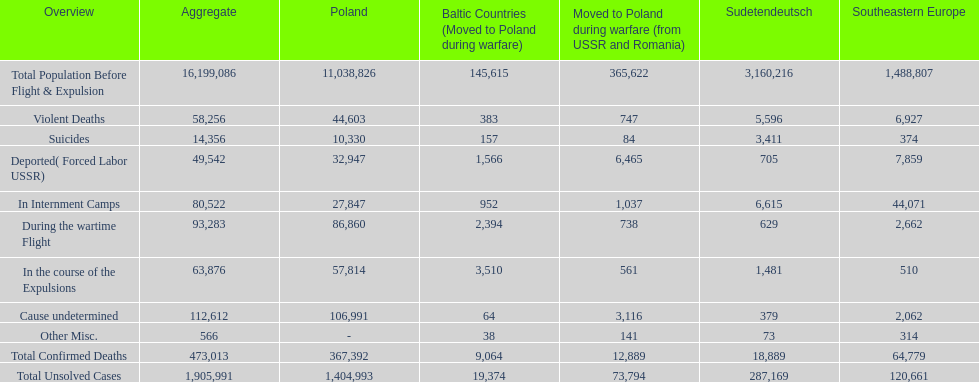Which region had the least total of unsolved cases? Baltic States(Resettled in Poland during war). 